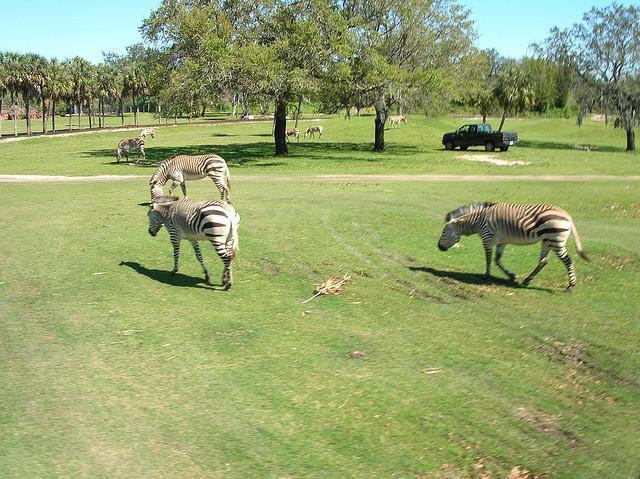What do the animals have?
Indicate the correct choice and explain in the format: 'Answer: answer
Rationale: rationale.'
Options: Long necks, stingers, stripes, talons. Answer: stripes.
Rationale: They have stripes. 